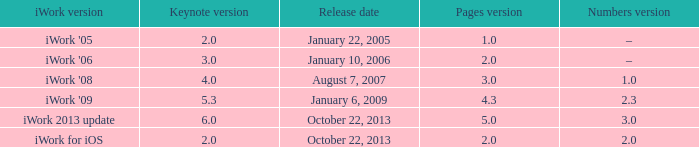What's the latest keynote version of version 2.3 of numbers with pages greater than 4.3? None. 